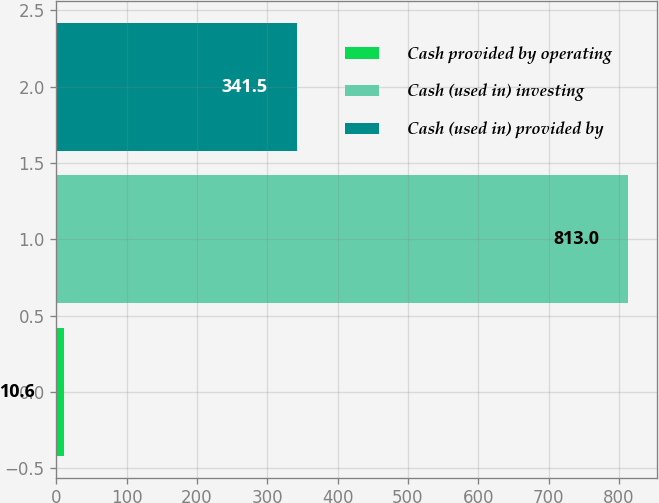<chart> <loc_0><loc_0><loc_500><loc_500><bar_chart><fcel>Cash provided by operating<fcel>Cash (used in) investing<fcel>Cash (used in) provided by<nl><fcel>10.6<fcel>813<fcel>341.5<nl></chart> 